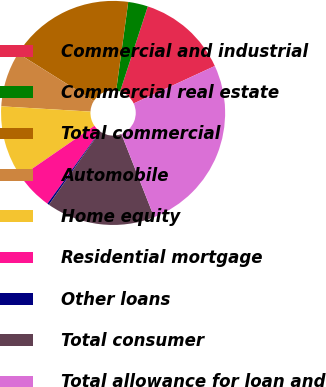<chart> <loc_0><loc_0><loc_500><loc_500><pie_chart><fcel>Commercial and industrial<fcel>Commercial real estate<fcel>Total commercial<fcel>Automobile<fcel>Home equity<fcel>Residential mortgage<fcel>Other loans<fcel>Total consumer<fcel>Total allowance for loan and<nl><fcel>13.11%<fcel>2.85%<fcel>18.24%<fcel>7.98%<fcel>10.55%<fcel>5.42%<fcel>0.26%<fcel>15.68%<fcel>25.91%<nl></chart> 